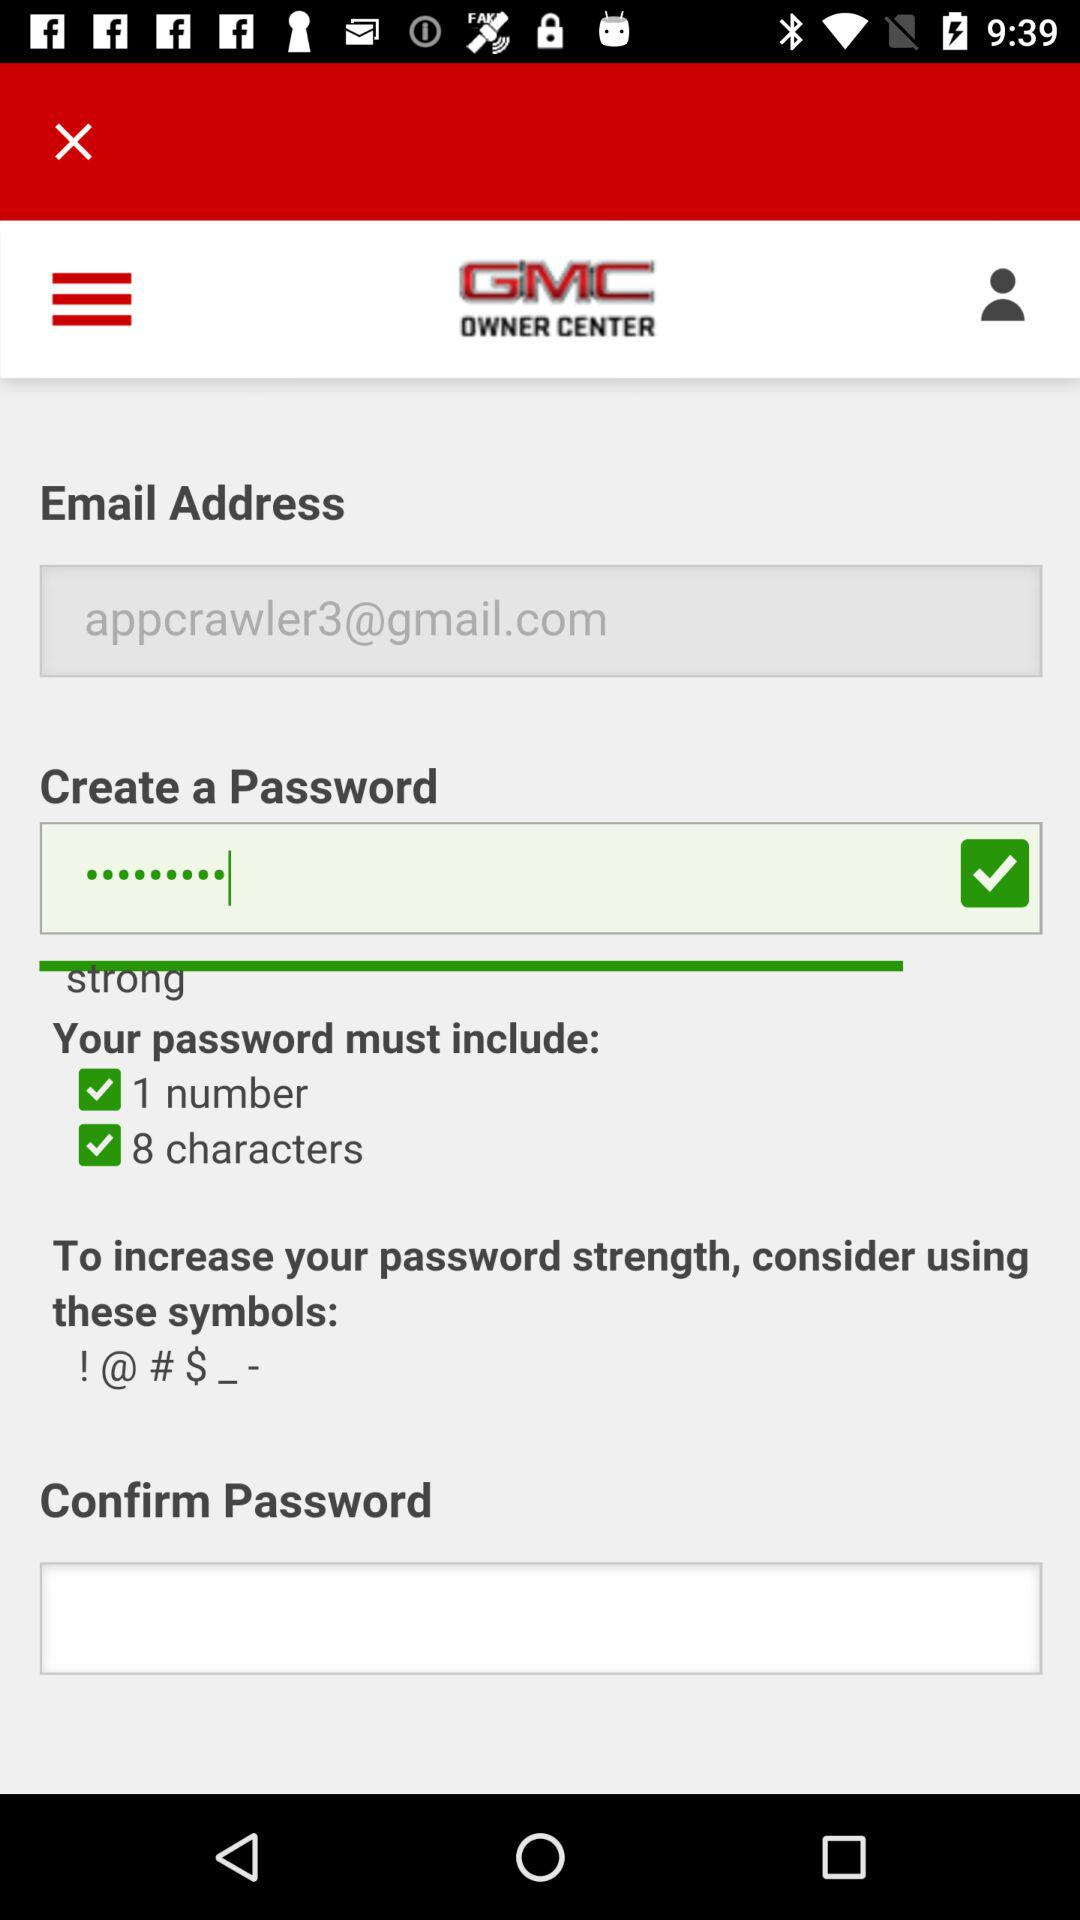What is the login email address? The login email address is appcrawler3@gmail.com. 